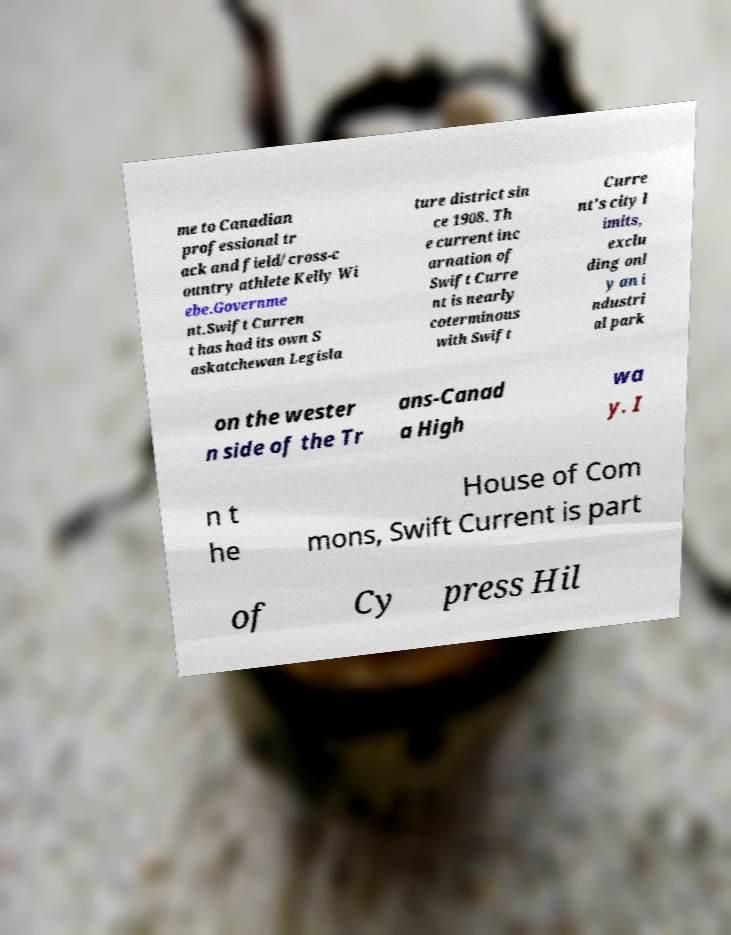Could you extract and type out the text from this image? me to Canadian professional tr ack and field/cross-c ountry athlete Kelly Wi ebe.Governme nt.Swift Curren t has had its own S askatchewan Legisla ture district sin ce 1908. Th e current inc arnation of Swift Curre nt is nearly coterminous with Swift Curre nt's city l imits, exclu ding onl y an i ndustri al park on the wester n side of the Tr ans-Canad a High wa y. I n t he House of Com mons, Swift Current is part of Cy press Hil 